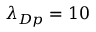<formula> <loc_0><loc_0><loc_500><loc_500>\lambda _ { D p } = 1 0</formula> 